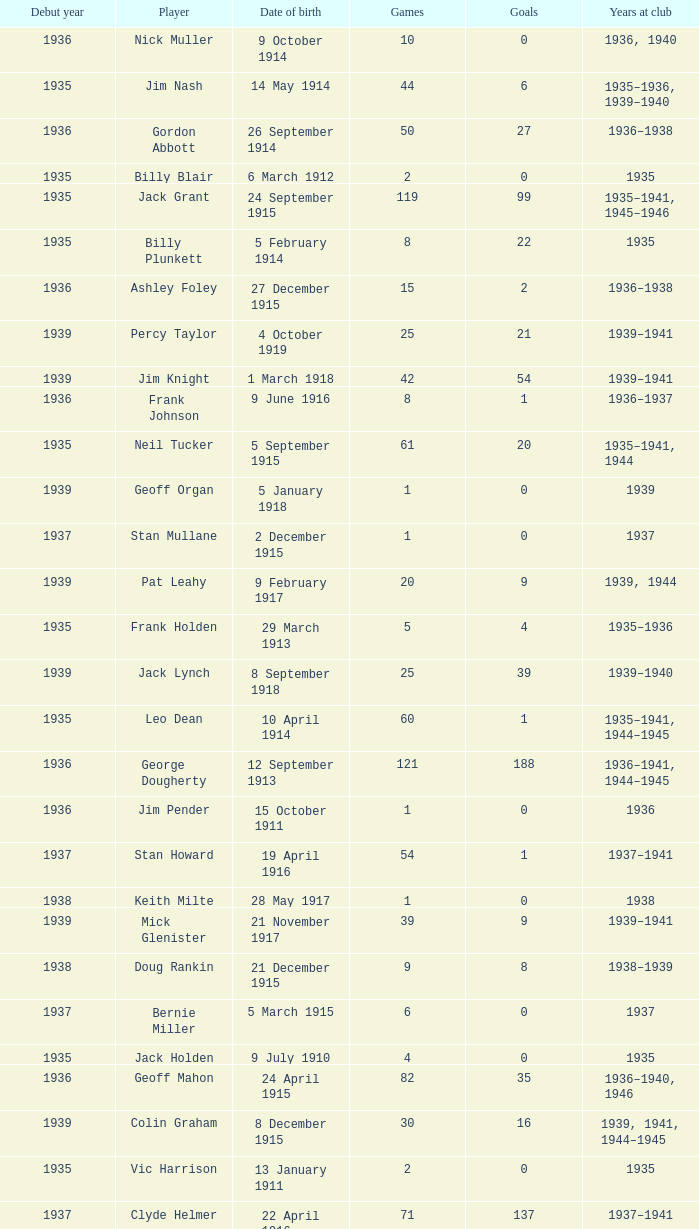What is the typical number of games played by a player born on 17 march 1915 and started before 1935? None. 